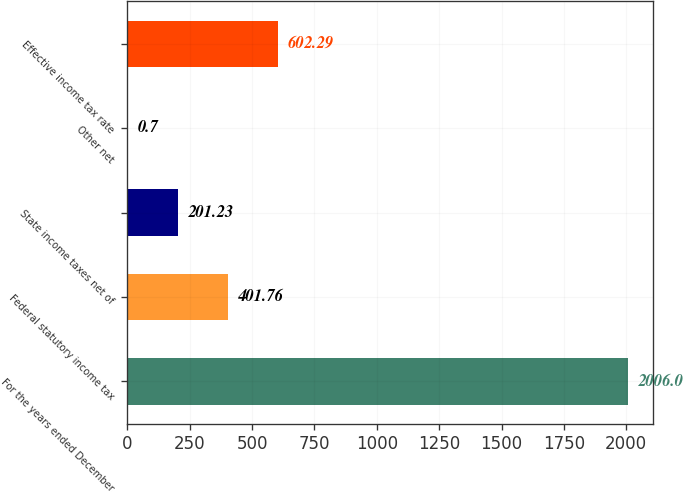Convert chart to OTSL. <chart><loc_0><loc_0><loc_500><loc_500><bar_chart><fcel>For the years ended December<fcel>Federal statutory income tax<fcel>State income taxes net of<fcel>Other net<fcel>Effective income tax rate<nl><fcel>2006<fcel>401.76<fcel>201.23<fcel>0.7<fcel>602.29<nl></chart> 